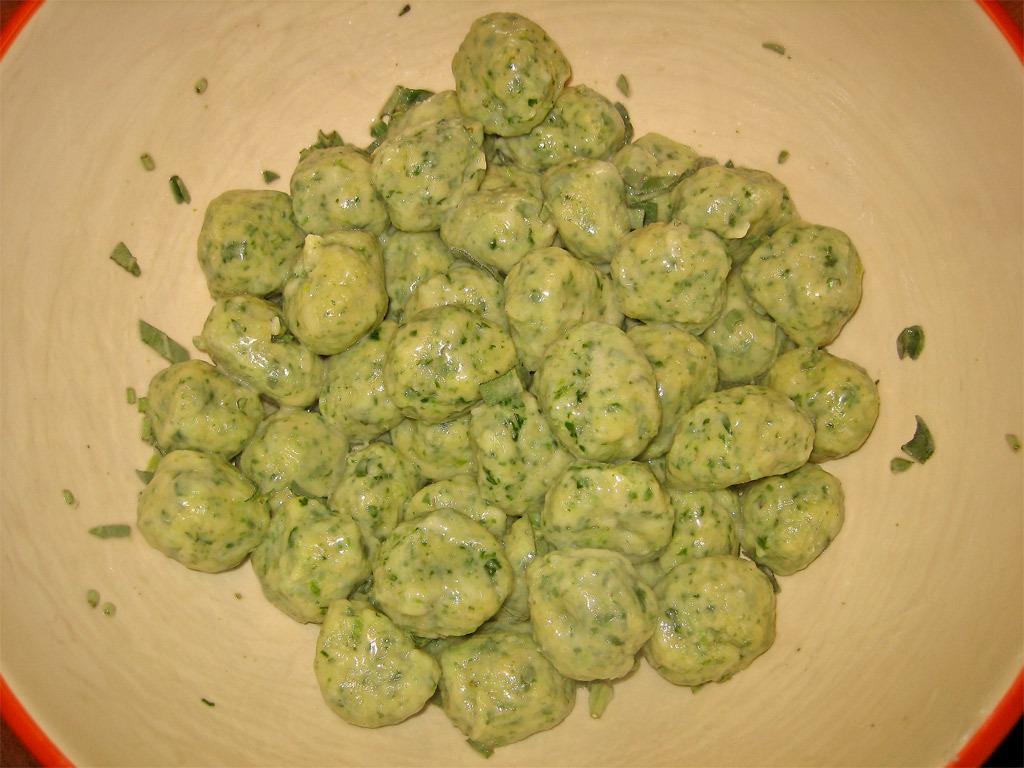Describe this image in one or two sentences. In this image I can see a bowl which is orange and cream in color and in the bowl I can see a food item which is cream and green in color. 